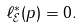<formula> <loc_0><loc_0><loc_500><loc_500>\ell _ { \mathcal { E } } ^ { * } ( p ) = 0 .</formula> 